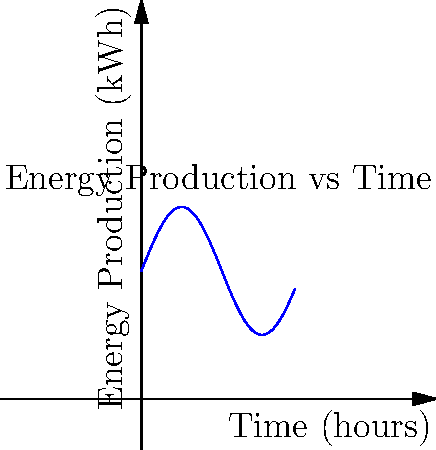A wind turbine's energy production varies over time as shown in the graph. If $E(t)$ represents the energy produced in kilowatt-hours (kWh) at time $t$ in hours, and $E(t) = 5\sin(\frac{t}{2}) + 10$, at what time during the first 12 hours is the rate of energy production increasing most rapidly? To find when the rate of energy production is increasing most rapidly, we need to find the maximum value of the second derivative of $E(t)$ within the given time range.

1. First derivative (rate of change of energy production):
   $E'(t) = \frac{d}{dt}(5\sin(\frac{t}{2}) + 10) = \frac{5}{2}\cos(\frac{t}{2})$

2. Second derivative (rate of change of the rate of change):
   $E''(t) = \frac{d}{dt}(\frac{5}{2}\cos(\frac{t}{2})) = -\frac{5}{4}\sin(\frac{t}{2})$

3. The second derivative is maximum when $\sin(\frac{t}{2})$ is minimum (most negative).

4. In the interval $[0, 12]$, $\sin(\frac{t}{2})$ is most negative at $t = 6$.

5. Verify: $E''(6) = -\frac{5}{4}\sin(3) \approx -1.03$, which is the most negative value in the interval.

Therefore, the rate of energy production is increasing most rapidly at $t = 6$ hours.
Answer: 6 hours 